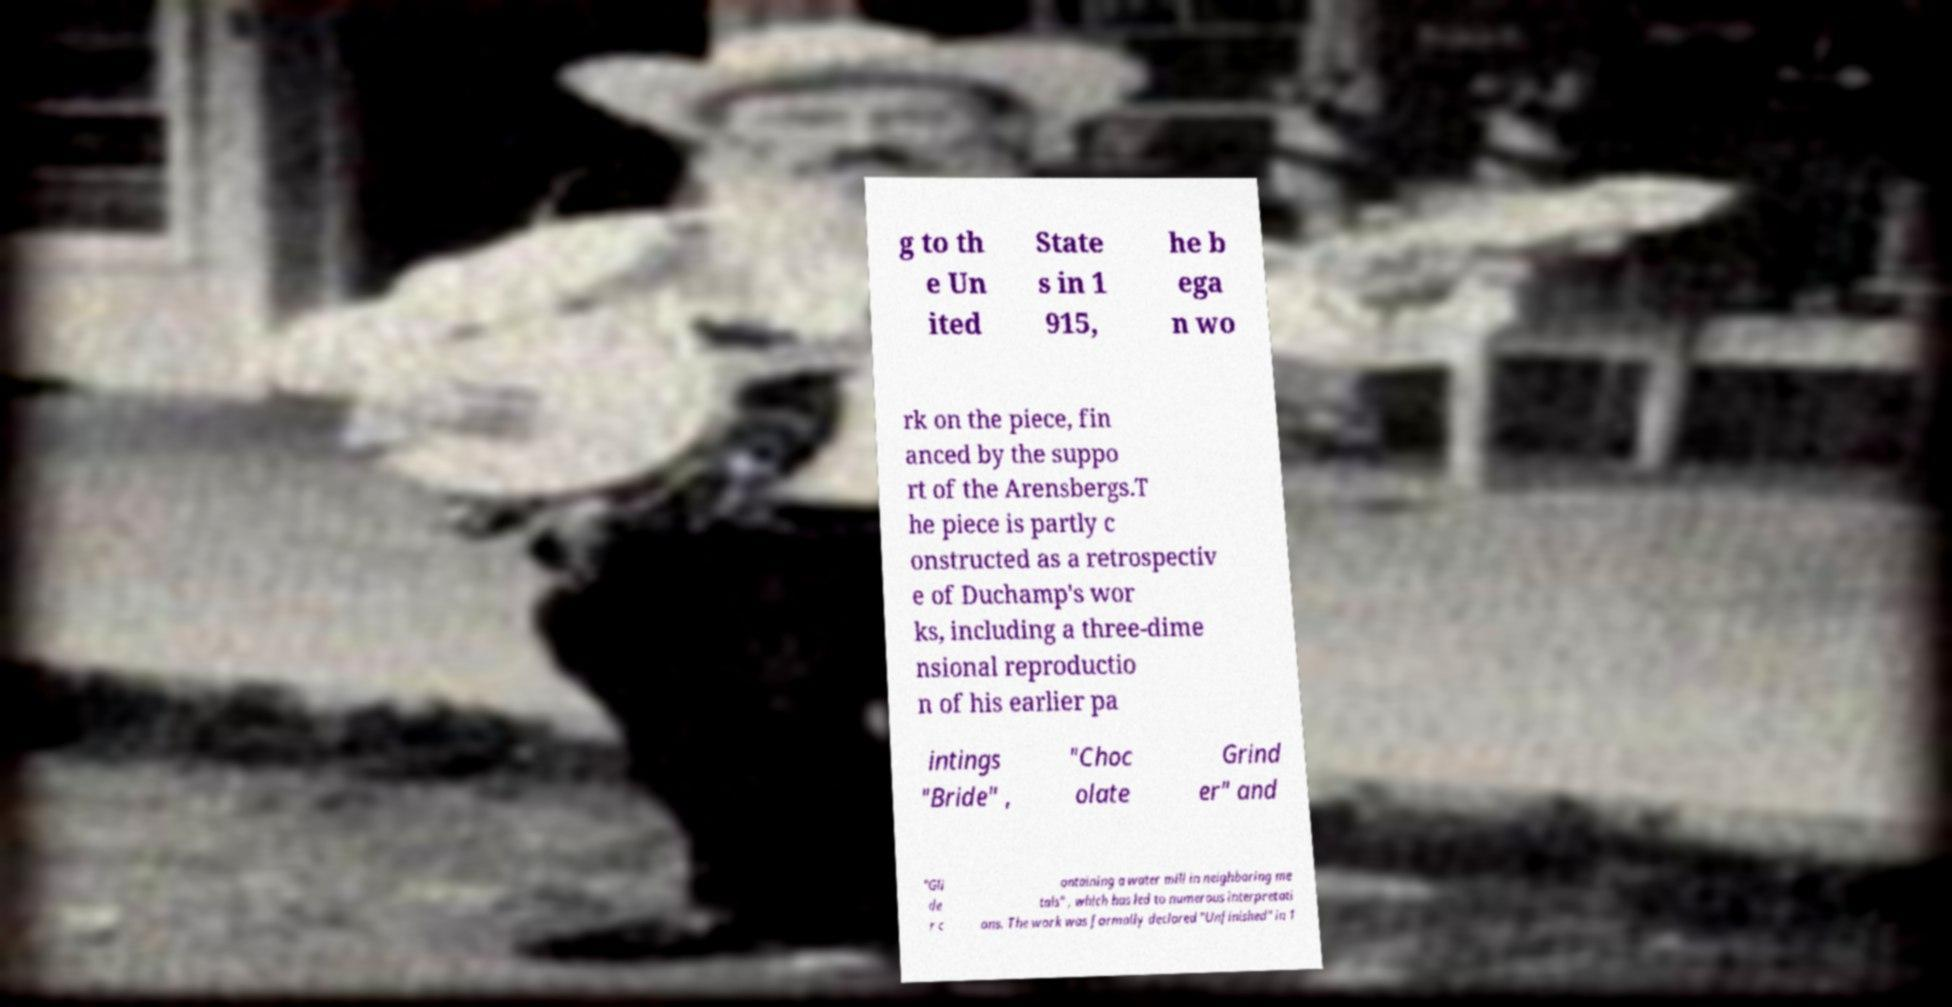Could you assist in decoding the text presented in this image and type it out clearly? g to th e Un ited State s in 1 915, he b ega n wo rk on the piece, fin anced by the suppo rt of the Arensbergs.T he piece is partly c onstructed as a retrospectiv e of Duchamp's wor ks, including a three-dime nsional reproductio n of his earlier pa intings "Bride" , "Choc olate Grind er" and "Gli de r c ontaining a water mill in neighboring me tals" , which has led to numerous interpretati ons. The work was formally declared "Unfinished" in 1 